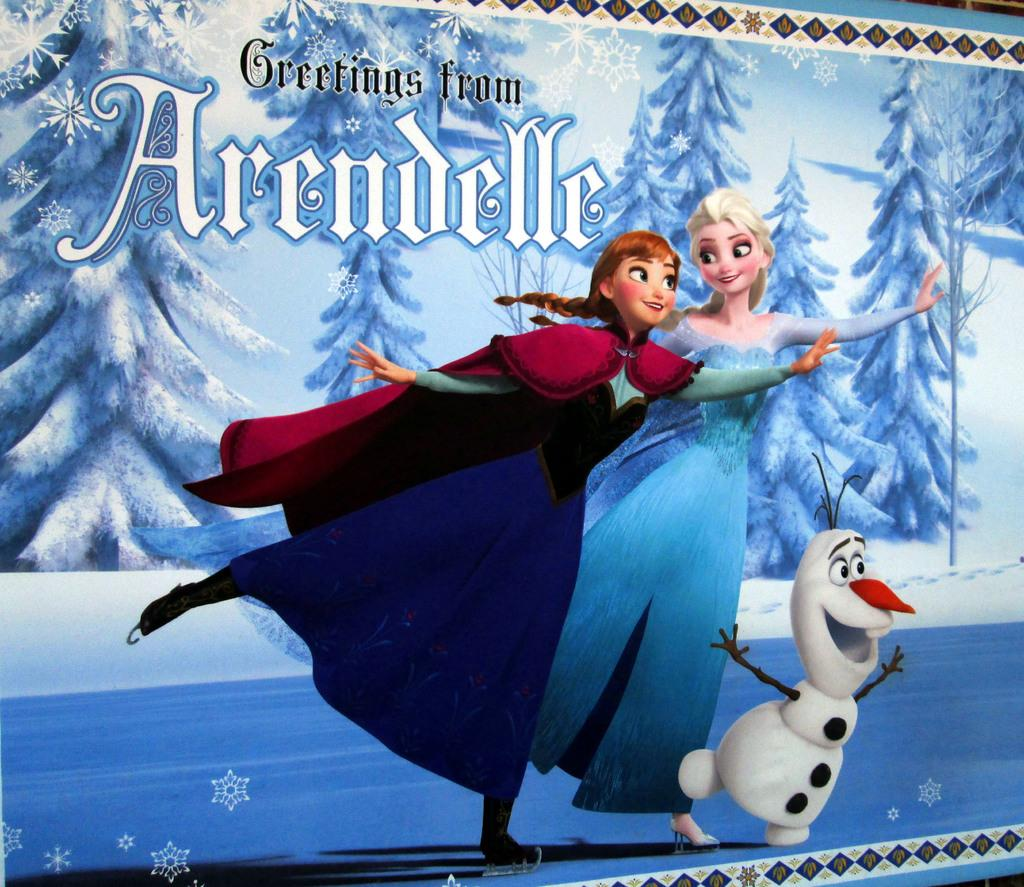<image>
Write a terse but informative summary of the picture. a poster that has greetings written on it 